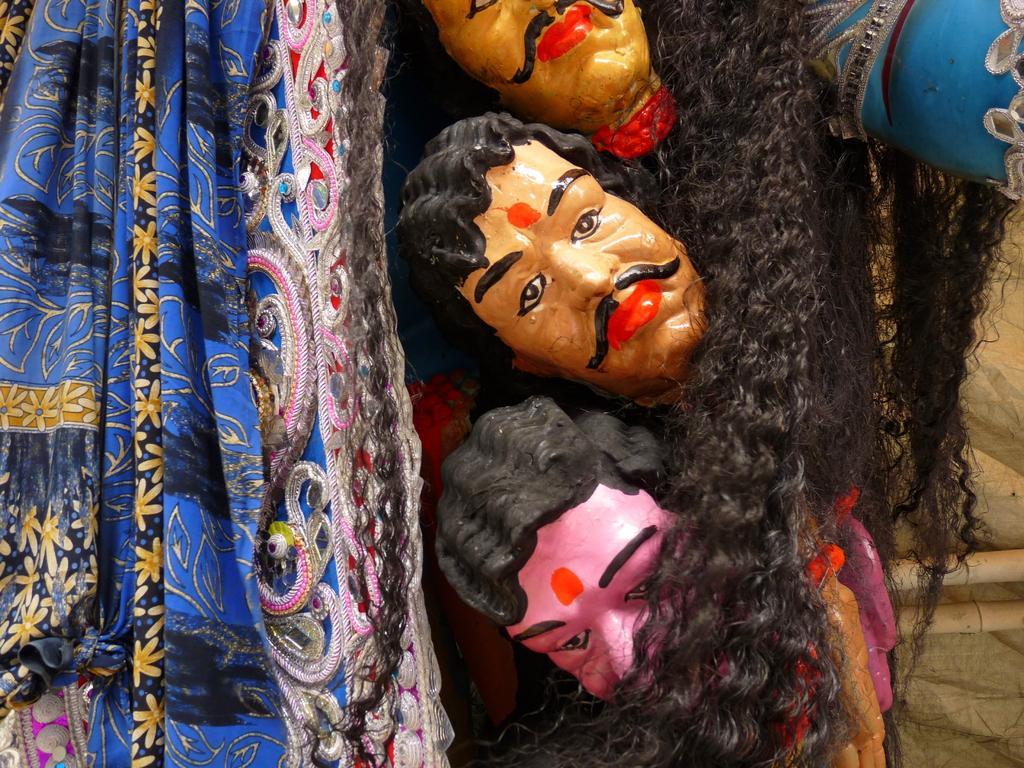How would you summarize this image in a sentence or two? This picture shows statues and we see a cloth and we see hair. 